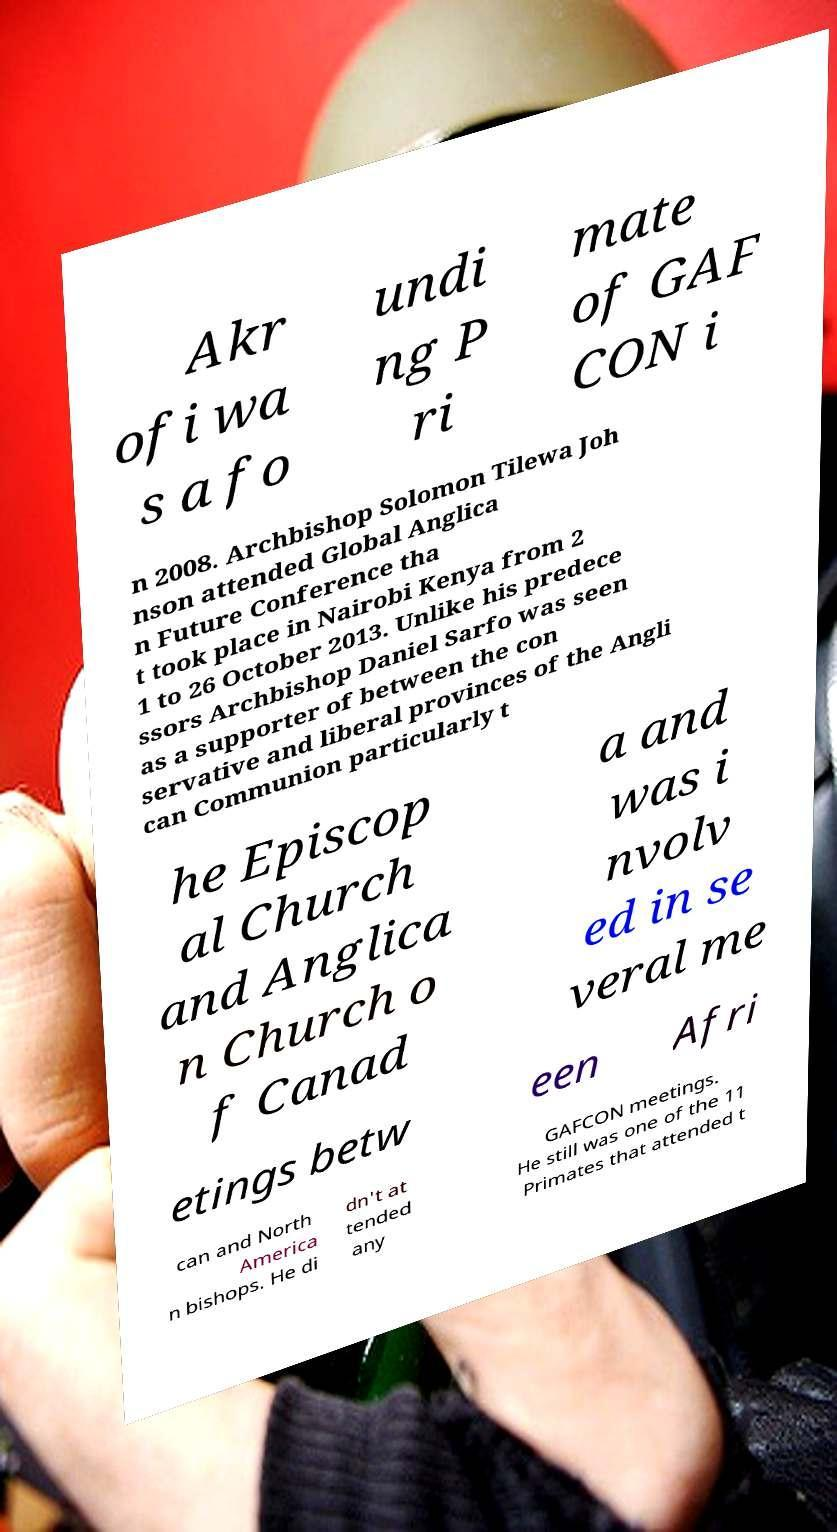Can you read and provide the text displayed in the image?This photo seems to have some interesting text. Can you extract and type it out for me? Akr ofi wa s a fo undi ng P ri mate of GAF CON i n 2008. Archbishop Solomon Tilewa Joh nson attended Global Anglica n Future Conference tha t took place in Nairobi Kenya from 2 1 to 26 October 2013. Unlike his predece ssors Archbishop Daniel Sarfo was seen as a supporter of between the con servative and liberal provinces of the Angli can Communion particularly t he Episcop al Church and Anglica n Church o f Canad a and was i nvolv ed in se veral me etings betw een Afri can and North America n bishops. He di dn't at tended any GAFCON meetings. He still was one of the 11 Primates that attended t 